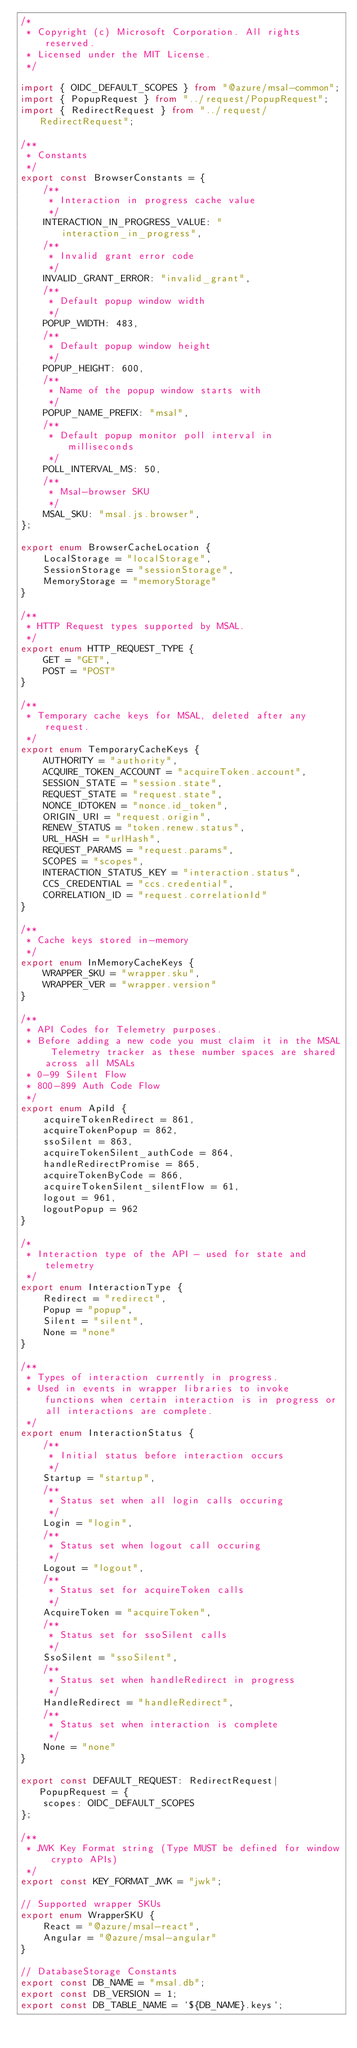Convert code to text. <code><loc_0><loc_0><loc_500><loc_500><_TypeScript_>/*
 * Copyright (c) Microsoft Corporation. All rights reserved.
 * Licensed under the MIT License.
 */

import { OIDC_DEFAULT_SCOPES } from "@azure/msal-common";
import { PopupRequest } from "../request/PopupRequest";
import { RedirectRequest } from "../request/RedirectRequest";

/**
 * Constants
 */
export const BrowserConstants = {
    /**
     * Interaction in progress cache value
     */
    INTERACTION_IN_PROGRESS_VALUE: "interaction_in_progress",
    /**
     * Invalid grant error code
     */
    INVALID_GRANT_ERROR: "invalid_grant",
    /**
     * Default popup window width
     */
    POPUP_WIDTH: 483,
    /**
     * Default popup window height
     */
    POPUP_HEIGHT: 600,
    /**
     * Name of the popup window starts with
     */
    POPUP_NAME_PREFIX: "msal",
    /**
     * Default popup monitor poll interval in milliseconds
     */
    POLL_INTERVAL_MS: 50,
    /**
     * Msal-browser SKU
     */
    MSAL_SKU: "msal.js.browser",
};

export enum BrowserCacheLocation {
    LocalStorage = "localStorage",
    SessionStorage = "sessionStorage",
    MemoryStorage = "memoryStorage"
}

/**
 * HTTP Request types supported by MSAL.
 */
export enum HTTP_REQUEST_TYPE {
    GET = "GET",
    POST = "POST"
}

/**
 * Temporary cache keys for MSAL, deleted after any request.
 */
export enum TemporaryCacheKeys {
    AUTHORITY = "authority",
    ACQUIRE_TOKEN_ACCOUNT = "acquireToken.account",
    SESSION_STATE = "session.state",
    REQUEST_STATE = "request.state",
    NONCE_IDTOKEN = "nonce.id_token",
    ORIGIN_URI = "request.origin",
    RENEW_STATUS = "token.renew.status",
    URL_HASH = "urlHash",
    REQUEST_PARAMS = "request.params",
    SCOPES = "scopes",
    INTERACTION_STATUS_KEY = "interaction.status",
    CCS_CREDENTIAL = "ccs.credential",
    CORRELATION_ID = "request.correlationId"
}

/**
 * Cache keys stored in-memory
 */
export enum InMemoryCacheKeys {
    WRAPPER_SKU = "wrapper.sku",
    WRAPPER_VER = "wrapper.version"
}

/**
 * API Codes for Telemetry purposes. 
 * Before adding a new code you must claim it in the MSAL Telemetry tracker as these number spaces are shared across all MSALs
 * 0-99 Silent Flow
 * 800-899 Auth Code Flow
 */
export enum ApiId {
    acquireTokenRedirect = 861,
    acquireTokenPopup = 862,
    ssoSilent = 863,
    acquireTokenSilent_authCode = 864,
    handleRedirectPromise = 865,
    acquireTokenByCode = 866,
    acquireTokenSilent_silentFlow = 61,
    logout = 961,
    logoutPopup = 962
}

/*
 * Interaction type of the API - used for state and telemetry
 */
export enum InteractionType {
    Redirect = "redirect",
    Popup = "popup",
    Silent = "silent",
    None = "none"
}

/**
 * Types of interaction currently in progress.
 * Used in events in wrapper libraries to invoke functions when certain interaction is in progress or all interactions are complete.
 */
export enum InteractionStatus {
    /**
     * Initial status before interaction occurs
     */
    Startup = "startup",
    /**
     * Status set when all login calls occuring
     */
    Login = "login",
    /**
     * Status set when logout call occuring
     */ 
    Logout = "logout",
    /**
     * Status set for acquireToken calls
     */
    AcquireToken = "acquireToken",
    /**
     * Status set for ssoSilent calls
     */
    SsoSilent = "ssoSilent",
    /**
     * Status set when handleRedirect in progress
     */
    HandleRedirect = "handleRedirect",
    /**
     * Status set when interaction is complete
     */
    None = "none"
}

export const DEFAULT_REQUEST: RedirectRequest|PopupRequest = {
    scopes: OIDC_DEFAULT_SCOPES
};

/**
 * JWK Key Format string (Type MUST be defined for window crypto APIs)
 */
export const KEY_FORMAT_JWK = "jwk";

// Supported wrapper SKUs
export enum WrapperSKU {
    React = "@azure/msal-react",
    Angular = "@azure/msal-angular"
}

// DatabaseStorage Constants
export const DB_NAME = "msal.db";
export const DB_VERSION = 1;
export const DB_TABLE_NAME = `${DB_NAME}.keys`;
</code> 